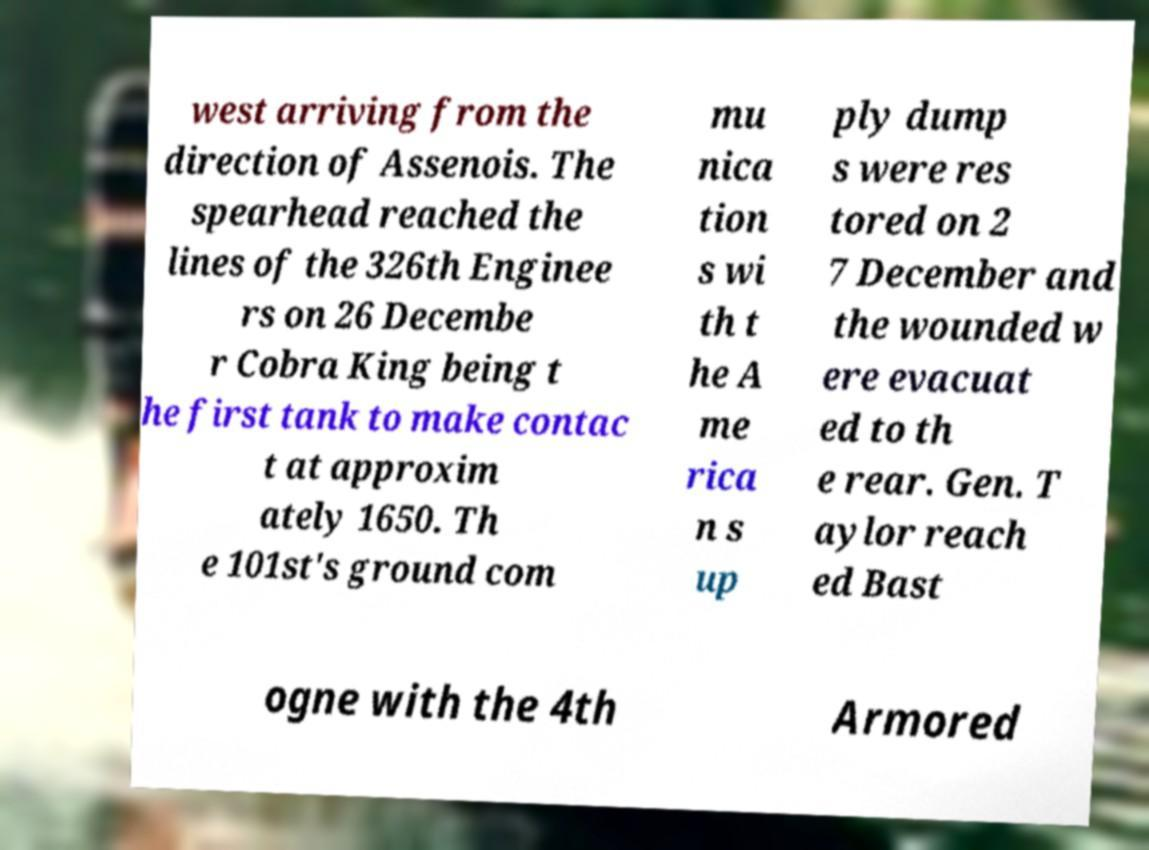Please identify and transcribe the text found in this image. west arriving from the direction of Assenois. The spearhead reached the lines of the 326th Enginee rs on 26 Decembe r Cobra King being t he first tank to make contac t at approxim ately 1650. Th e 101st's ground com mu nica tion s wi th t he A me rica n s up ply dump s were res tored on 2 7 December and the wounded w ere evacuat ed to th e rear. Gen. T aylor reach ed Bast ogne with the 4th Armored 